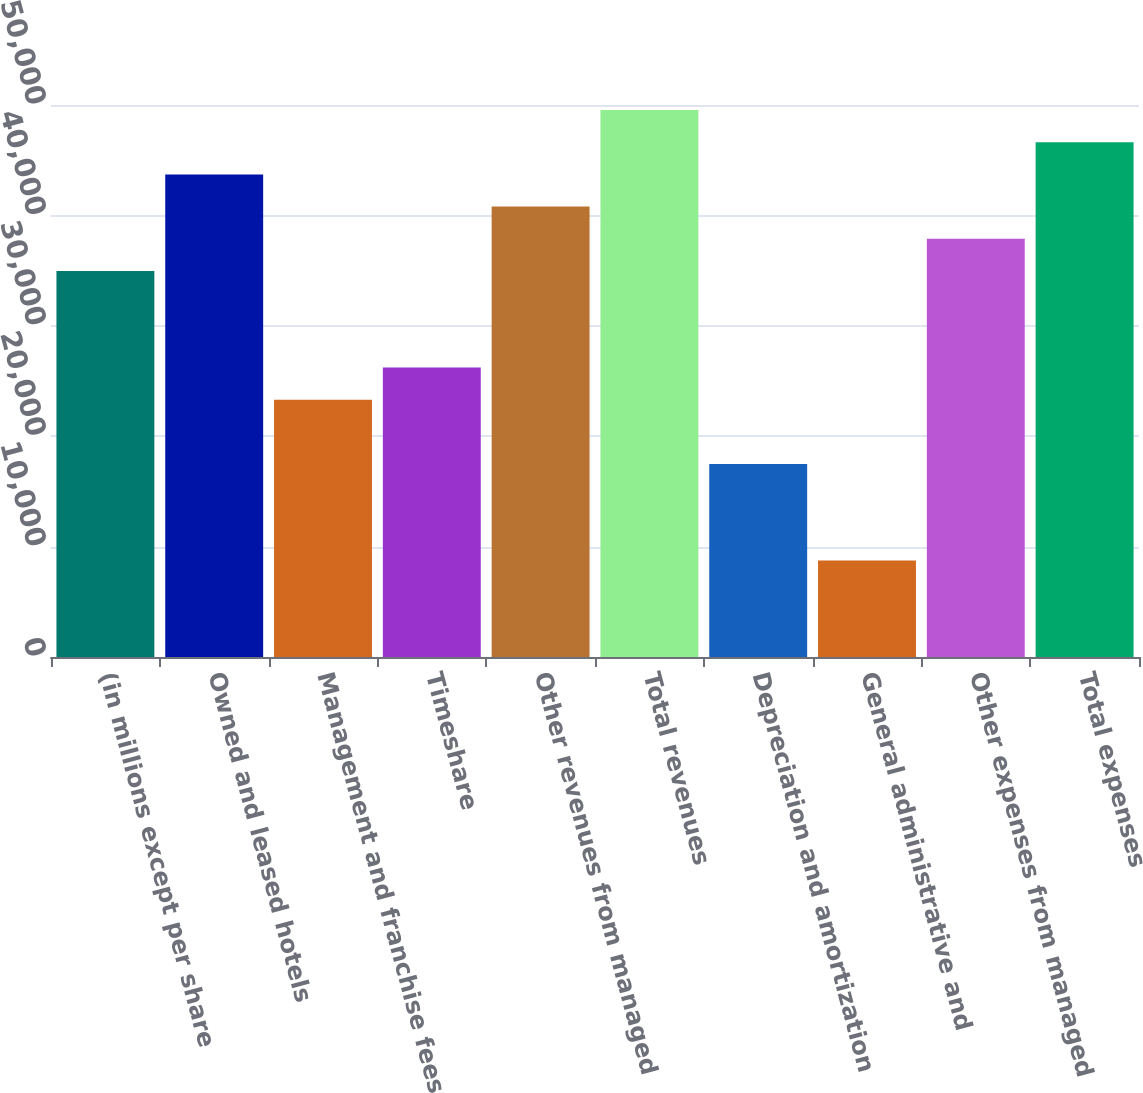<chart> <loc_0><loc_0><loc_500><loc_500><bar_chart><fcel>(in millions except per share<fcel>Owned and leased hotels<fcel>Management and franchise fees<fcel>Timeshare<fcel>Other revenues from managed<fcel>Total revenues<fcel>Depreciation and amortization<fcel>General administrative and<fcel>Other expenses from managed<fcel>Total expenses<nl><fcel>34967.9<fcel>43709.7<fcel>23312.1<fcel>26226<fcel>40795.7<fcel>49537.6<fcel>17484.2<fcel>8742.4<fcel>37881.8<fcel>46623.6<nl></chart> 